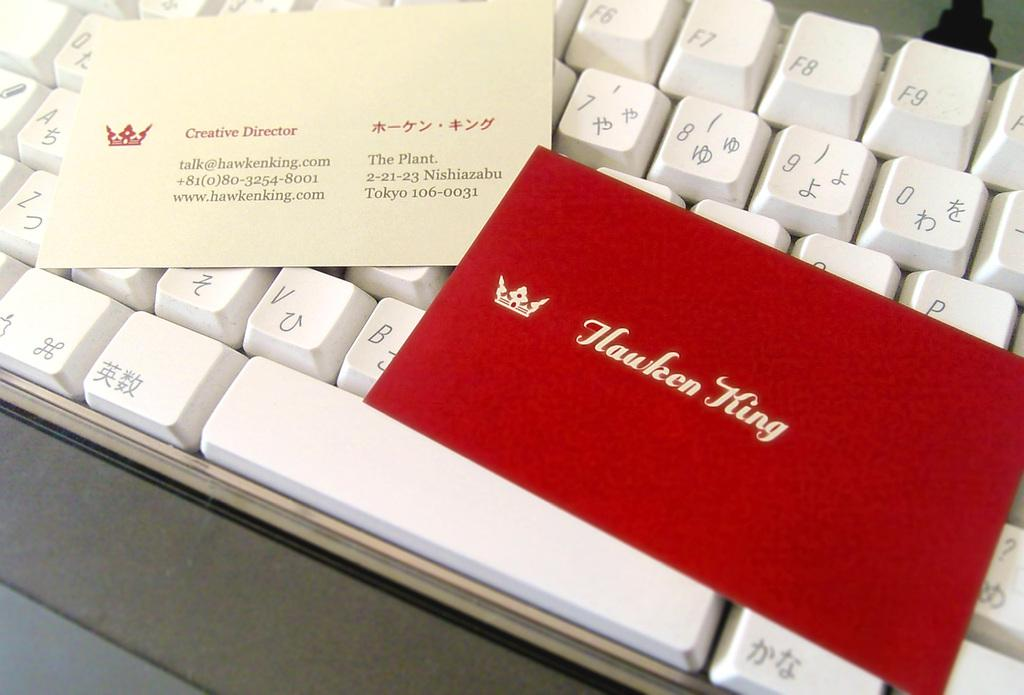<image>
Give a short and clear explanation of the subsequent image. A business card from the Creative Director is sitting on top of a white keyboard. 